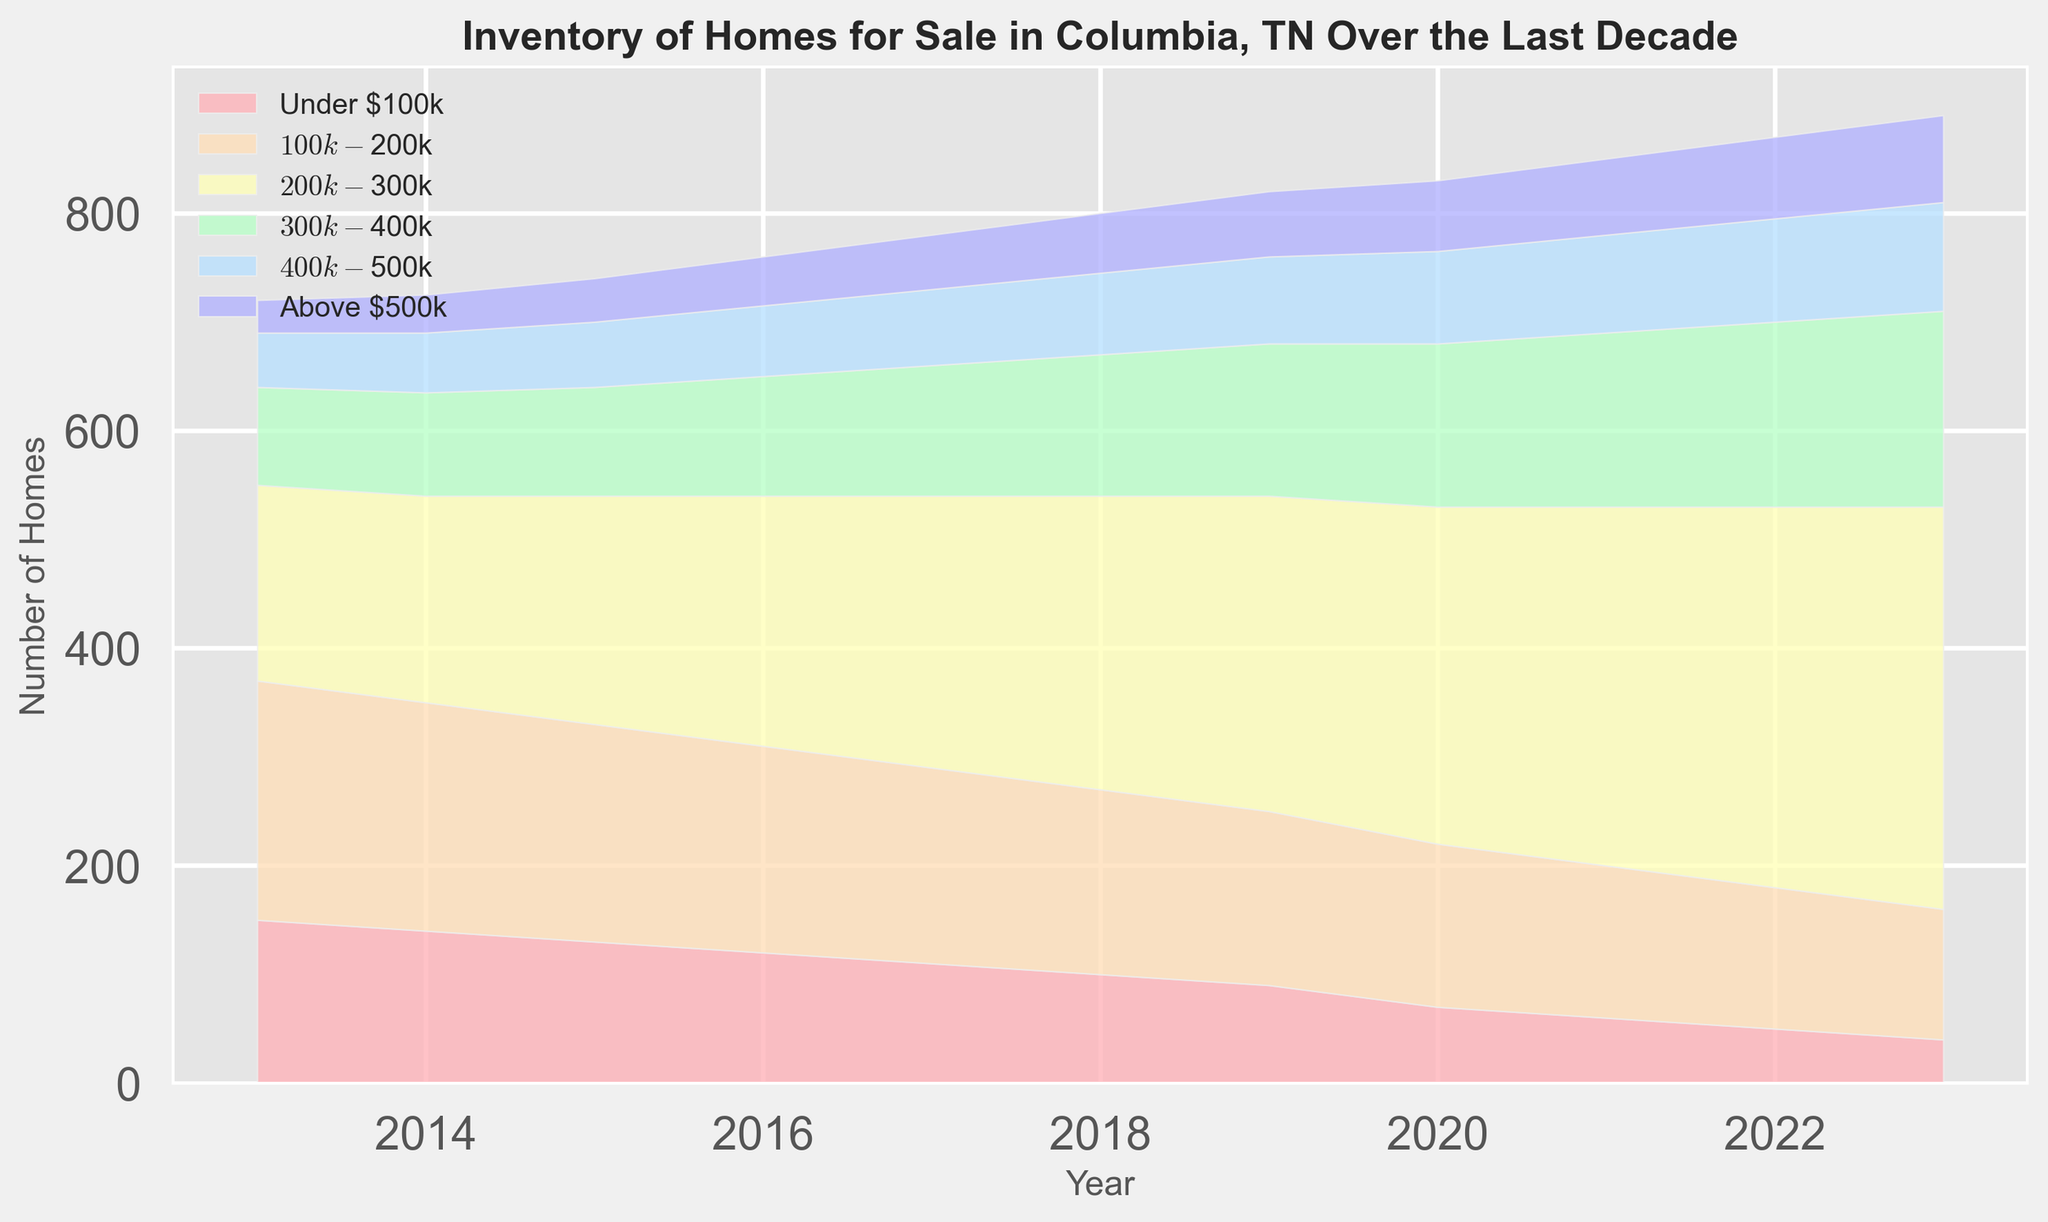What's the general trend of homes under $100k from 2013 to 2023? The chart shows a declining trend in the number of homes under $100k, decreasing from 150 in 2013 to 40 in 2023. This trend is visualized by the reduction in the area representing this price range.
Answer: Declining Which price range had the most significant increase in inventory over the decade? The inventory of homes in the $200k-$300k range saw the most significant increase. We can observe this by noting the area representing this range, which grew from 180 in 2013 to 370 in 2023, an increase of 190 homes.
Answer: $200k-$300k In which year did the $300k-$400k range surpass the $100k-$200k range in inventory? By examining the heights of the areas in the chart, we can see that the $300k-$400k range surpassed the $100k-$200k range in 2021, where the former reached 160 and the latter was at 140.
Answer: 2021 What is the total inventory of homes for sale in 2023 across all price ranges? To find the total inventory in 2023, sum the inventory values for all price ranges: 40 (Under $100k) + 120 ($100k-$200k) + 370 ($200k-$300k) + 180 ($300k-$400k) + 100 ($400k-$500k) + 80 (Above $500k). This totals to 890 homes.
Answer: 890 Which price range had a relatively consistent number of homes throughout the decade? The $400k-$500k range had a relatively consistent inventory, increasing gradually from 50 homes in 2013 to 100 homes in 2023. The slow and steady growth is less significant compared to other price ranges.
Answer: $400k-$500k How did the inventory of homes above $500k change from 2013 to 2023? Homes above $500k increased from 30 in 2013 to 80 in 2023. This trend can be seen clearly with the growing area representing this price range.
Answer: Increased What's the difference in the number of homes in the $200k-$300k range between 2015 and 2023? The number of homes in the $200k-$300k range in 2015 was 210, and in 2023 it was 370. The difference is 370 - 210 = 160 homes.
Answer: 160 Which year shows the greatest total inventory of homes for sale? By examining the chart, 2023 shows the greatest total inventory, where the sum of all price range areas is at its maximum.
Answer: 2023 What is the sum of the number of homes in the $100k-$200k and $300k-$400k ranges in 2019? In 2019, the $100k-$200k range had 160 homes and the $300k-$400k range had 140 homes. The sum is 160 + 140 = 300 homes.
Answer: 300 